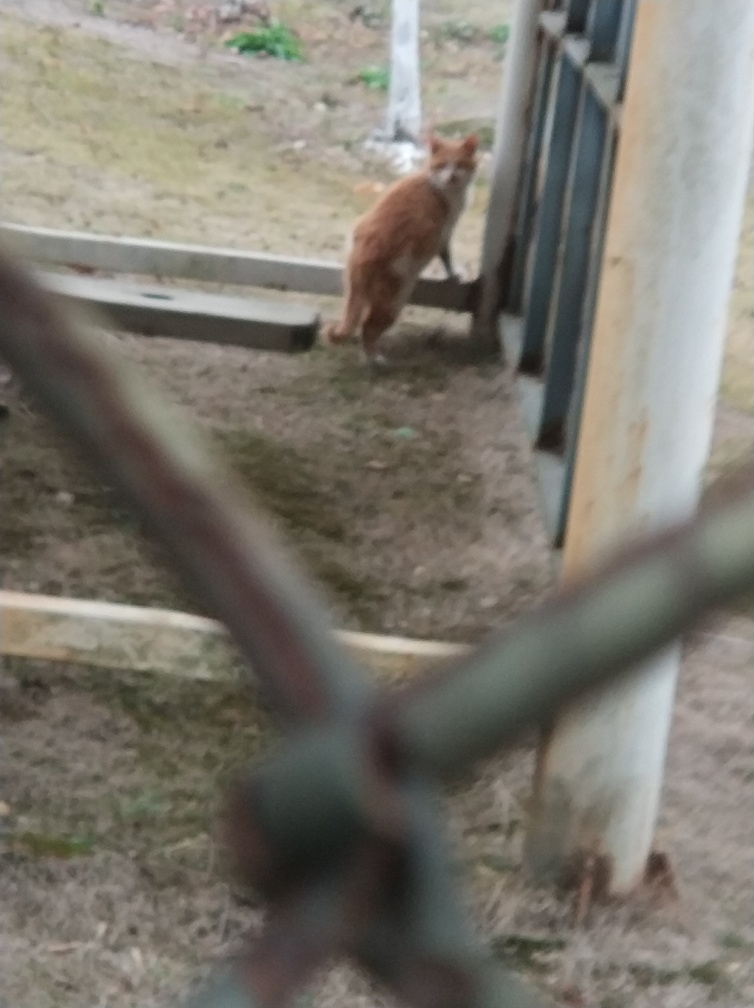What is the weather like in this image? The lighting in the image is overcast, lacking strong shadows or bright sunlight, which may indicate a cloudy or overcast day. 